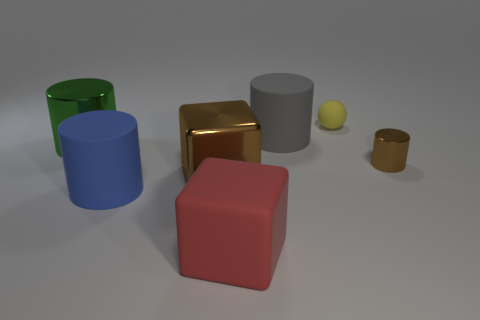What size is the brown metal object to the right of the red matte cube in front of the tiny brown shiny thing?
Offer a terse response. Small. What is the color of the other shiny thing that is the same shape as the small metal thing?
Provide a succinct answer. Green. Does the blue cylinder have the same size as the yellow matte object?
Offer a terse response. No. Are there the same number of yellow rubber objects behind the yellow thing and big purple spheres?
Keep it short and to the point. Yes. There is a block that is left of the large red thing; is there a big cylinder on the left side of it?
Keep it short and to the point. Yes. There is a shiny cylinder that is left of the tiny rubber sphere left of the metal cylinder that is to the right of the large red object; how big is it?
Your answer should be compact. Large. There is a large gray thing that is on the left side of the shiny cylinder on the right side of the big green metallic thing; what is it made of?
Offer a terse response. Rubber. Are there any other objects of the same shape as the red rubber thing?
Make the answer very short. Yes. There is a small shiny object; what shape is it?
Provide a short and direct response. Cylinder. What is the material of the brown thing that is right of the brown metallic thing that is left of the large object on the right side of the big red object?
Your answer should be compact. Metal. 